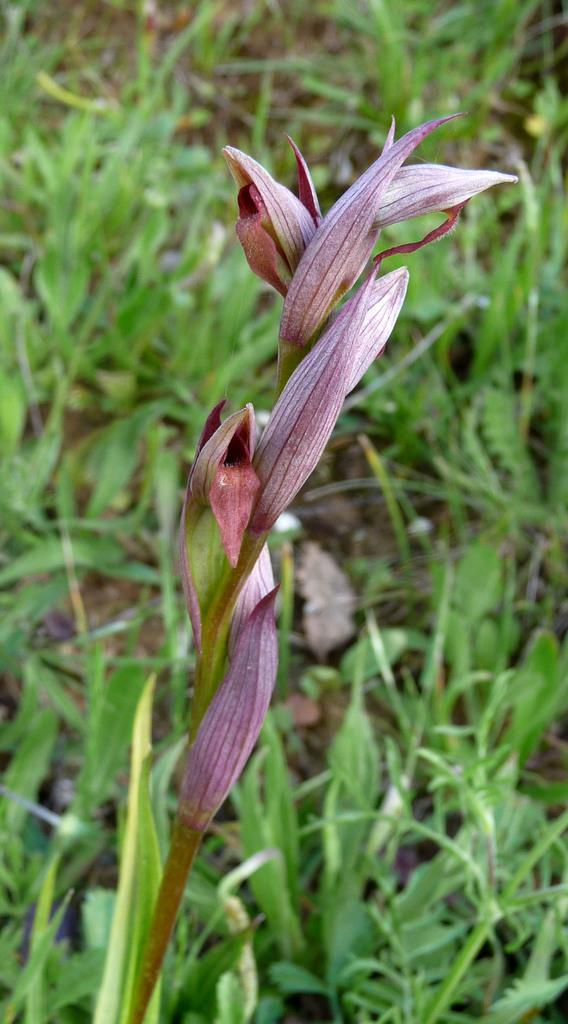What type of vegetation is visible in the front of the image? There are flowers in the front of the image. What can be seen in the background of the image? There are plants in the background of the image. Are there any screws visible in the image? There are no screws present in the image. What type of giants can be seen interacting with the plants in the image? There are no giants present in the image; it features flowers and plants only. 